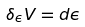<formula> <loc_0><loc_0><loc_500><loc_500>\delta _ { \epsilon } V = d \epsilon</formula> 